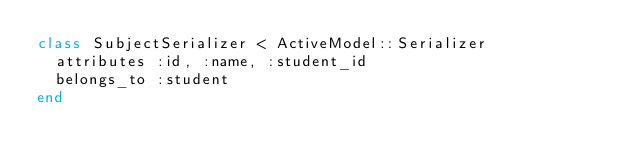<code> <loc_0><loc_0><loc_500><loc_500><_Ruby_>class SubjectSerializer < ActiveModel::Serializer
  attributes :id, :name, :student_id
  belongs_to :student
end
</code> 